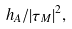<formula> <loc_0><loc_0><loc_500><loc_500>h _ { A } / | \tau _ { M } | ^ { 2 } ,</formula> 